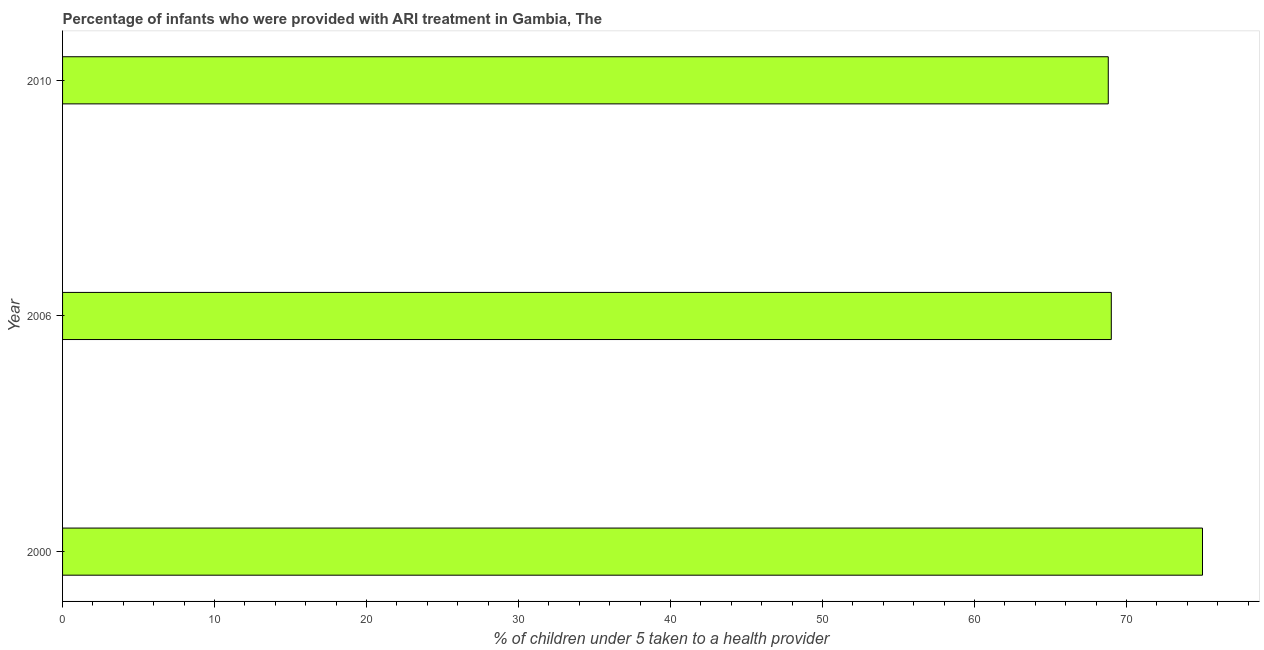Does the graph contain grids?
Give a very brief answer. No. What is the title of the graph?
Provide a short and direct response. Percentage of infants who were provided with ARI treatment in Gambia, The. What is the label or title of the X-axis?
Give a very brief answer. % of children under 5 taken to a health provider. Across all years, what is the minimum percentage of children who were provided with ari treatment?
Keep it short and to the point. 68.8. What is the sum of the percentage of children who were provided with ari treatment?
Provide a succinct answer. 212.8. What is the average percentage of children who were provided with ari treatment per year?
Give a very brief answer. 70.93. In how many years, is the percentage of children who were provided with ari treatment greater than 6 %?
Offer a terse response. 3. What is the ratio of the percentage of children who were provided with ari treatment in 2000 to that in 2010?
Keep it short and to the point. 1.09. What is the difference between the highest and the second highest percentage of children who were provided with ari treatment?
Provide a short and direct response. 6. Is the sum of the percentage of children who were provided with ari treatment in 2000 and 2006 greater than the maximum percentage of children who were provided with ari treatment across all years?
Make the answer very short. Yes. What is the difference between the highest and the lowest percentage of children who were provided with ari treatment?
Provide a short and direct response. 6.2. Are all the bars in the graph horizontal?
Your response must be concise. Yes. How many years are there in the graph?
Ensure brevity in your answer.  3. What is the difference between two consecutive major ticks on the X-axis?
Ensure brevity in your answer.  10. What is the % of children under 5 taken to a health provider of 2010?
Give a very brief answer. 68.8. What is the difference between the % of children under 5 taken to a health provider in 2006 and 2010?
Your answer should be very brief. 0.2. What is the ratio of the % of children under 5 taken to a health provider in 2000 to that in 2006?
Offer a terse response. 1.09. What is the ratio of the % of children under 5 taken to a health provider in 2000 to that in 2010?
Keep it short and to the point. 1.09. 